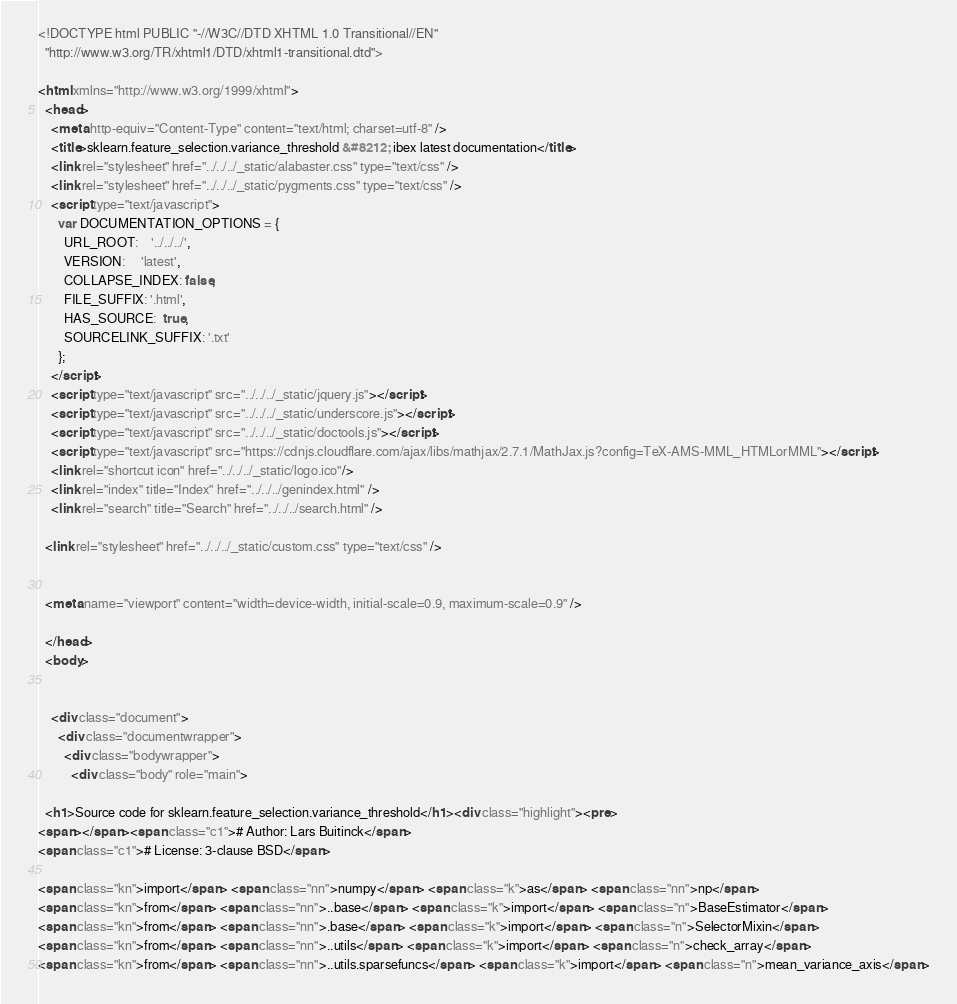<code> <loc_0><loc_0><loc_500><loc_500><_HTML_>
<!DOCTYPE html PUBLIC "-//W3C//DTD XHTML 1.0 Transitional//EN"
  "http://www.w3.org/TR/xhtml1/DTD/xhtml1-transitional.dtd">

<html xmlns="http://www.w3.org/1999/xhtml">
  <head>
    <meta http-equiv="Content-Type" content="text/html; charset=utf-8" />
    <title>sklearn.feature_selection.variance_threshold &#8212; ibex latest documentation</title>
    <link rel="stylesheet" href="../../../_static/alabaster.css" type="text/css" />
    <link rel="stylesheet" href="../../../_static/pygments.css" type="text/css" />
    <script type="text/javascript">
      var DOCUMENTATION_OPTIONS = {
        URL_ROOT:    '../../../',
        VERSION:     'latest',
        COLLAPSE_INDEX: false,
        FILE_SUFFIX: '.html',
        HAS_SOURCE:  true,
        SOURCELINK_SUFFIX: '.txt'
      };
    </script>
    <script type="text/javascript" src="../../../_static/jquery.js"></script>
    <script type="text/javascript" src="../../../_static/underscore.js"></script>
    <script type="text/javascript" src="../../../_static/doctools.js"></script>
    <script type="text/javascript" src="https://cdnjs.cloudflare.com/ajax/libs/mathjax/2.7.1/MathJax.js?config=TeX-AMS-MML_HTMLorMML"></script>
    <link rel="shortcut icon" href="../../../_static/logo.ico"/>
    <link rel="index" title="Index" href="../../../genindex.html" />
    <link rel="search" title="Search" href="../../../search.html" />
   
  <link rel="stylesheet" href="../../../_static/custom.css" type="text/css" />
  
  
  <meta name="viewport" content="width=device-width, initial-scale=0.9, maximum-scale=0.9" />

  </head>
  <body>
  

    <div class="document">
      <div class="documentwrapper">
        <div class="bodywrapper">
          <div class="body" role="main">
            
  <h1>Source code for sklearn.feature_selection.variance_threshold</h1><div class="highlight"><pre>
<span></span><span class="c1"># Author: Lars Buitinck</span>
<span class="c1"># License: 3-clause BSD</span>

<span class="kn">import</span> <span class="nn">numpy</span> <span class="k">as</span> <span class="nn">np</span>
<span class="kn">from</span> <span class="nn">..base</span> <span class="k">import</span> <span class="n">BaseEstimator</span>
<span class="kn">from</span> <span class="nn">.base</span> <span class="k">import</span> <span class="n">SelectorMixin</span>
<span class="kn">from</span> <span class="nn">..utils</span> <span class="k">import</span> <span class="n">check_array</span>
<span class="kn">from</span> <span class="nn">..utils.sparsefuncs</span> <span class="k">import</span> <span class="n">mean_variance_axis</span></code> 